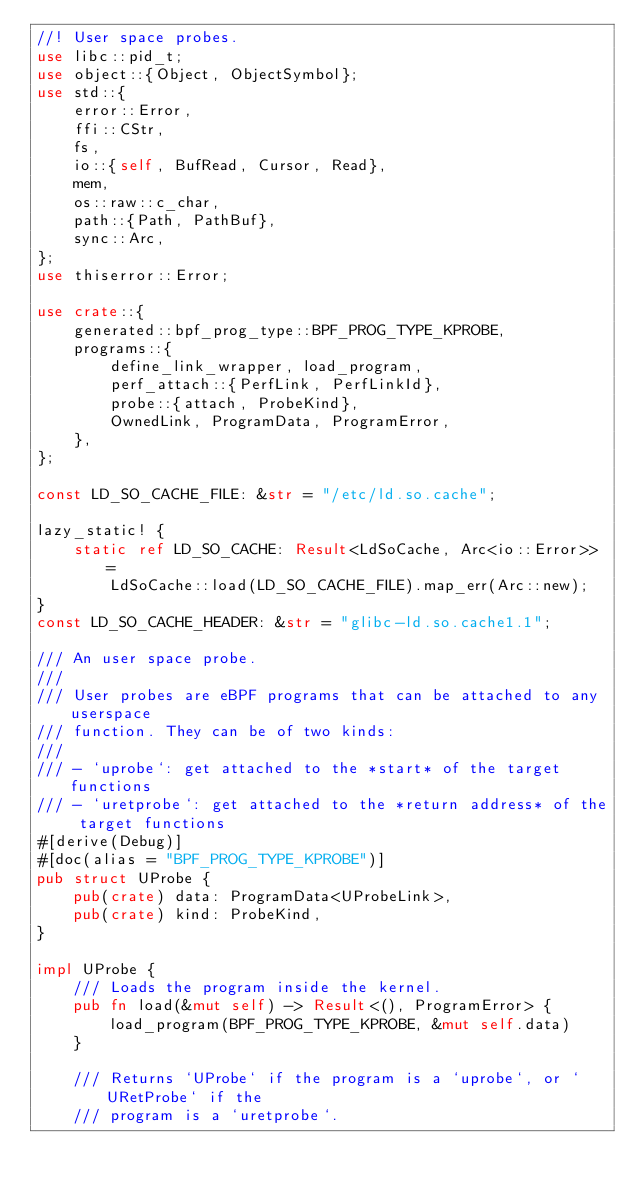Convert code to text. <code><loc_0><loc_0><loc_500><loc_500><_Rust_>//! User space probes.
use libc::pid_t;
use object::{Object, ObjectSymbol};
use std::{
    error::Error,
    ffi::CStr,
    fs,
    io::{self, BufRead, Cursor, Read},
    mem,
    os::raw::c_char,
    path::{Path, PathBuf},
    sync::Arc,
};
use thiserror::Error;

use crate::{
    generated::bpf_prog_type::BPF_PROG_TYPE_KPROBE,
    programs::{
        define_link_wrapper, load_program,
        perf_attach::{PerfLink, PerfLinkId},
        probe::{attach, ProbeKind},
        OwnedLink, ProgramData, ProgramError,
    },
};

const LD_SO_CACHE_FILE: &str = "/etc/ld.so.cache";

lazy_static! {
    static ref LD_SO_CACHE: Result<LdSoCache, Arc<io::Error>> =
        LdSoCache::load(LD_SO_CACHE_FILE).map_err(Arc::new);
}
const LD_SO_CACHE_HEADER: &str = "glibc-ld.so.cache1.1";

/// An user space probe.
///
/// User probes are eBPF programs that can be attached to any userspace
/// function. They can be of two kinds:
///
/// - `uprobe`: get attached to the *start* of the target functions
/// - `uretprobe`: get attached to the *return address* of the target functions
#[derive(Debug)]
#[doc(alias = "BPF_PROG_TYPE_KPROBE")]
pub struct UProbe {
    pub(crate) data: ProgramData<UProbeLink>,
    pub(crate) kind: ProbeKind,
}

impl UProbe {
    /// Loads the program inside the kernel.
    pub fn load(&mut self) -> Result<(), ProgramError> {
        load_program(BPF_PROG_TYPE_KPROBE, &mut self.data)
    }

    /// Returns `UProbe` if the program is a `uprobe`, or `URetProbe` if the
    /// program is a `uretprobe`.</code> 